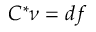<formula> <loc_0><loc_0><loc_500><loc_500>C ^ { * } \nu = d f</formula> 